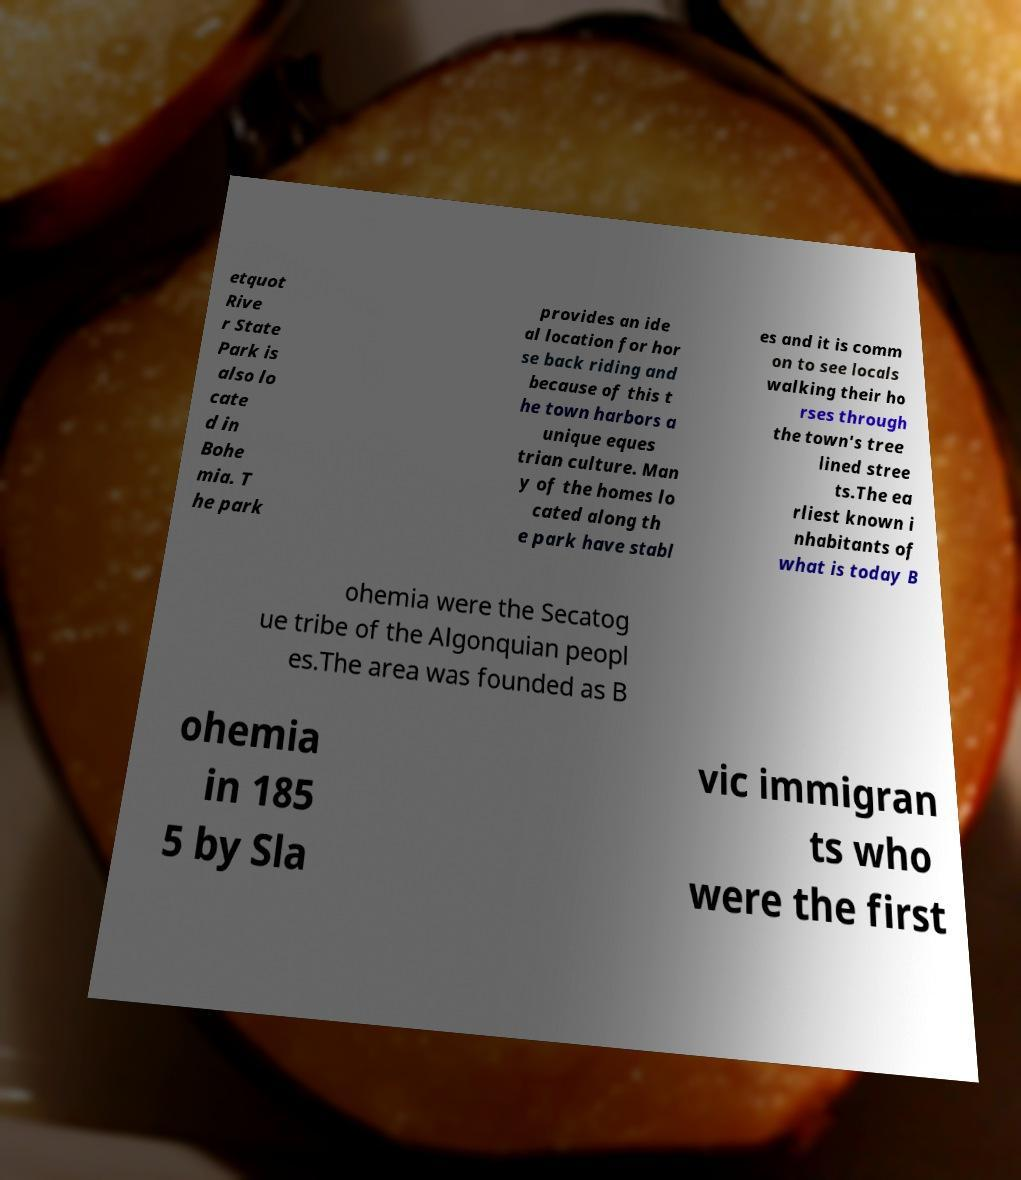For documentation purposes, I need the text within this image transcribed. Could you provide that? etquot Rive r State Park is also lo cate d in Bohe mia. T he park provides an ide al location for hor se back riding and because of this t he town harbors a unique eques trian culture. Man y of the homes lo cated along th e park have stabl es and it is comm on to see locals walking their ho rses through the town's tree lined stree ts.The ea rliest known i nhabitants of what is today B ohemia were the Secatog ue tribe of the Algonquian peopl es.The area was founded as B ohemia in 185 5 by Sla vic immigran ts who were the first 